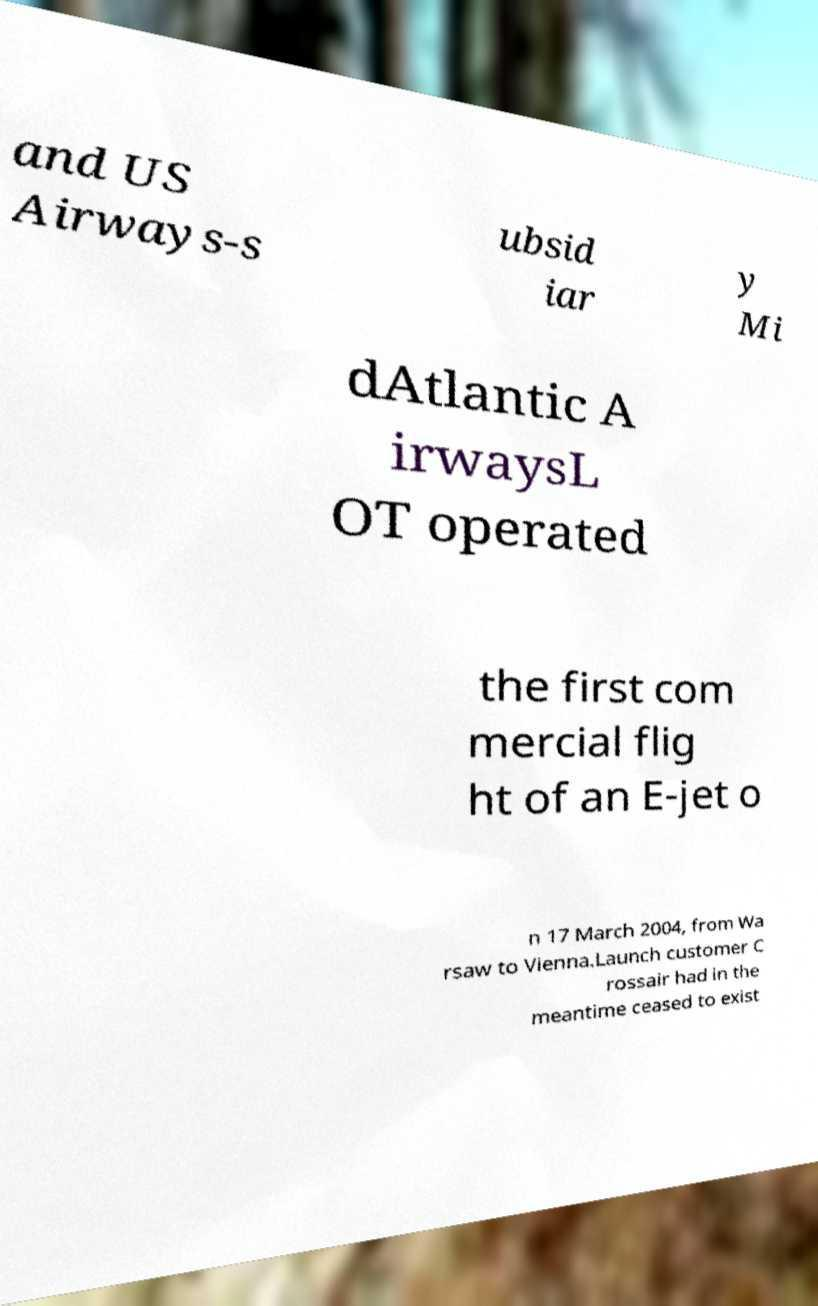Could you extract and type out the text from this image? and US Airways-s ubsid iar y Mi dAtlantic A irwaysL OT operated the first com mercial flig ht of an E-jet o n 17 March 2004, from Wa rsaw to Vienna.Launch customer C rossair had in the meantime ceased to exist 